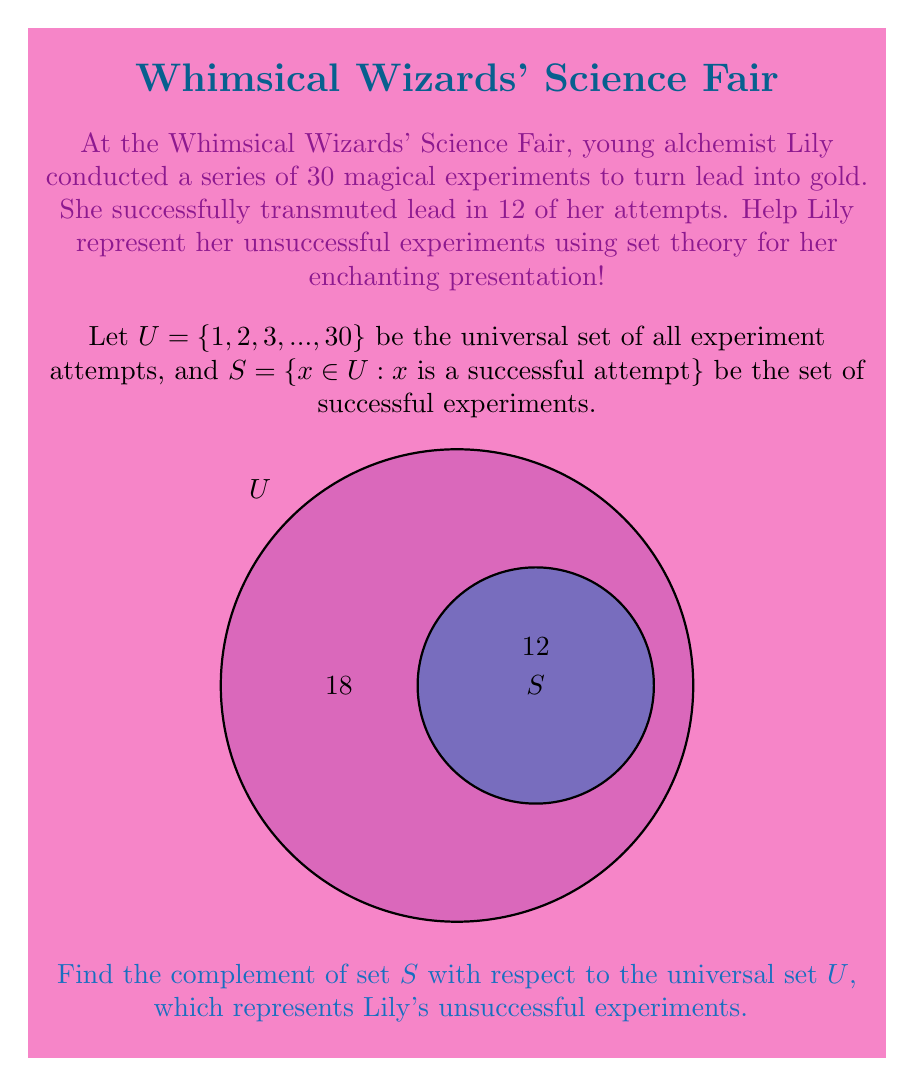Teach me how to tackle this problem. To find the complement of set $S$ with respect to the universal set $U$, we follow these steps:

1) First, recall that the complement of a set $A$ with respect to the universal set $U$ is defined as:

   $A^c = \{x \in U : x \notin A\}$

2) In this case, we're looking for $S^c$, which represents all elements in $U$ that are not in $S$.

3) We know that:
   - $U$ has 30 elements (all experiment attempts)
   - $S$ has 12 elements (successful experiments)

4) Therefore, $S^c$ will contain all the elements of $U$ that are not in $S$. The number of elements in $S^c$ will be:

   $|S^c| = |U| - |S| = 30 - 12 = 18$

5) While we don't know the specific numbers of the unsuccessful experiments, we can represent $S^c$ as:

   $S^c = \{x \in U : x \text{ is an unsuccessful attempt}\}$

This set contains all the elements of $U$ that are not in $S$, which are precisely the unsuccessful experiments.
Answer: $S^c = \{x \in U : x \text{ is an unsuccessful attempt}\}$ 